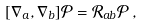Convert formula to latex. <formula><loc_0><loc_0><loc_500><loc_500>[ \nabla _ { a } , \nabla _ { b } ] \mathcal { P } = \mathcal { R } _ { a b } \mathcal { P } \, ,</formula> 